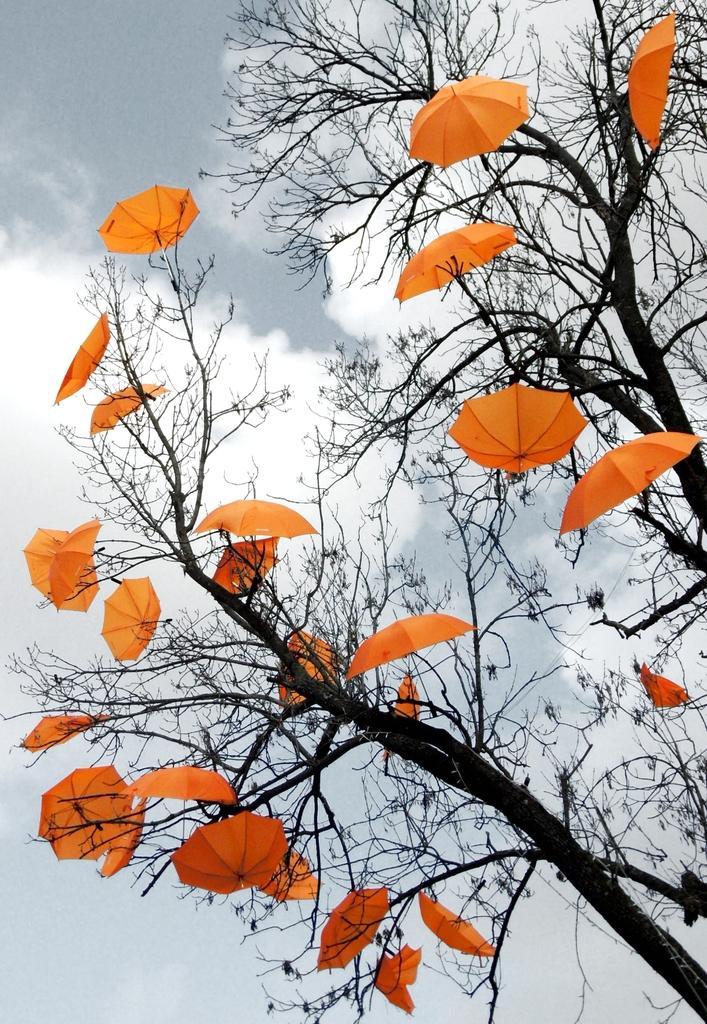Can you describe this image briefly? In this picture we can see there are trees with umbrellas. Behind the trees there is the sky. 